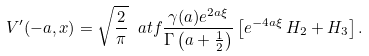Convert formula to latex. <formula><loc_0><loc_0><loc_500><loc_500>V ^ { \prime } ( - a , x ) = \sqrt { \frac { 2 } { \pi } } \ a t f \frac { \gamma ( a ) e ^ { 2 a \xi } } { \Gamma \left ( a + \frac { 1 } { 2 } \right ) } \left [ e ^ { - 4 a \xi } \, H _ { 2 } + H _ { 3 } \right ] .</formula> 